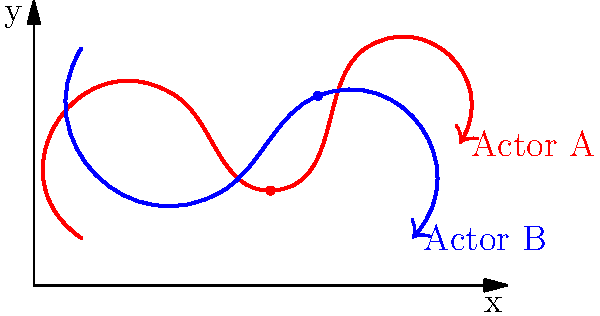In the controversial scene depicted by the vector paths, at what point do the two actors come closest to each other? Express your answer as coordinates (x, y). To find the point where the two actors come closest to each other, we need to analyze their movement patterns represented by the vector paths:

1. Actor A's path (red): $(1,1) \to (3,4) \to (5,2) \to (7,5) \to (9,3)$
2. Actor B's path (blue): $(1,5) \to (4,2) \to (6,4) \to (8,1)$

To determine the closest point:

1. Identify potential crossing or near-miss points:
   - Around $(4,3)$ and $(5.5,3)$

2. Estimate the coordinates for each actor at these points:
   - Actor A: approximately $(5,2)$
   - Actor B: approximately $(6,4)$

3. Calculate the distance between these points:
   $d = \sqrt{(x_2-x_1)^2 + (y_2-y_1)^2}$
   $d = \sqrt{(6-5)^2 + (4-2)^2} = \sqrt{1^2 + 2^2} = \sqrt{5} \approx 2.24$

4. This is the smallest distance between the two paths, occurring when:
   - Actor A is at $(5,2)$
   - Actor B is at $(6,4)$

5. The midpoint between these coordinates represents the point of closest approach:
   $(\frac{5+6}{2}, \frac{2+4}{2}) = (5.5, 3)$

Therefore, the point where the two actors come closest to each other is approximately $(5.5, 3)$.
Answer: $(5.5, 3)$ 